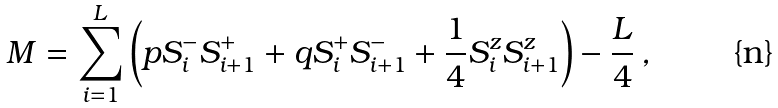<formula> <loc_0><loc_0><loc_500><loc_500>M = \sum _ { i = 1 } ^ { L } \left ( p S ^ { - } _ { i } S ^ { + } _ { i + 1 } + q S ^ { + } _ { i } S ^ { - } _ { i + 1 } + \frac { 1 } { 4 } S ^ { z } _ { i } S ^ { z } _ { i + 1 } \right ) - \frac { L } { 4 } \, ,</formula> 